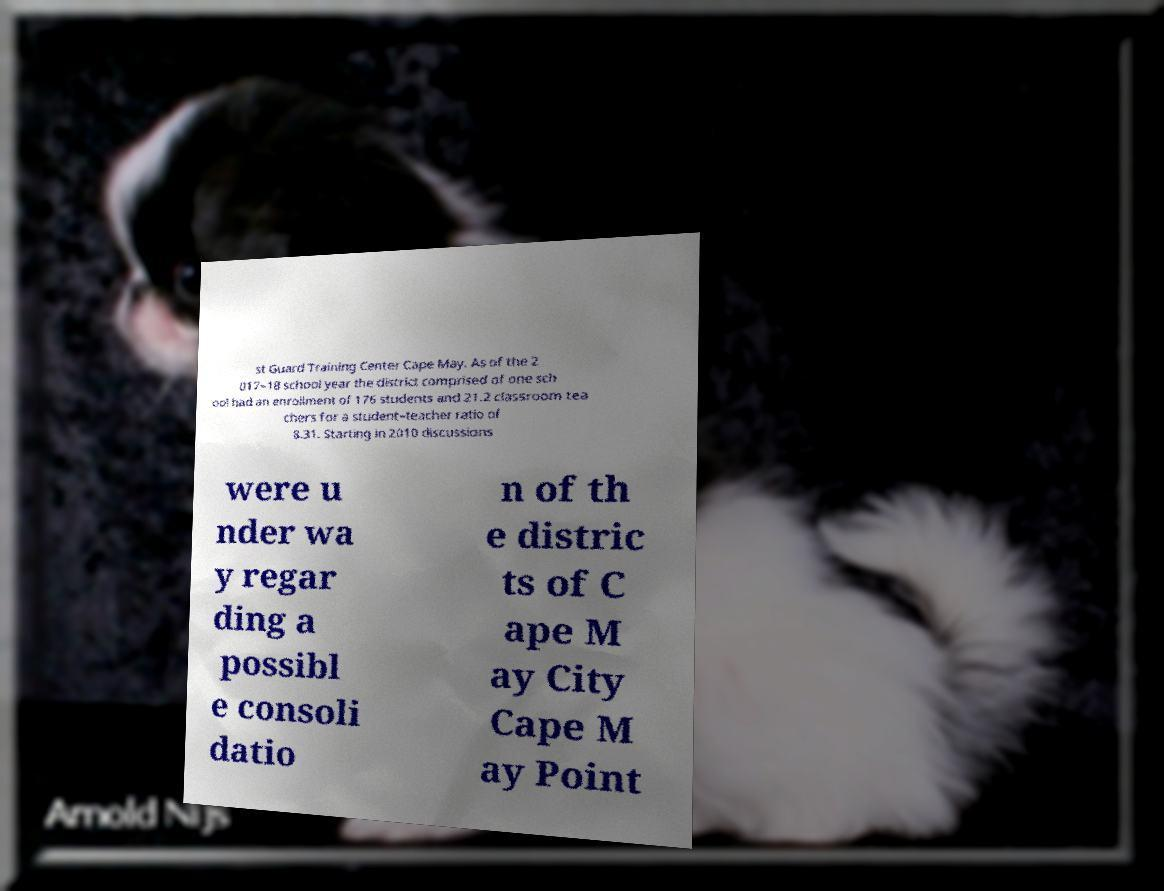Can you accurately transcribe the text from the provided image for me? st Guard Training Center Cape May. As of the 2 017–18 school year the district comprised of one sch ool had an enrollment of 176 students and 21.2 classroom tea chers for a student–teacher ratio of 8.31. Starting in 2010 discussions were u nder wa y regar ding a possibl e consoli datio n of th e distric ts of C ape M ay City Cape M ay Point 